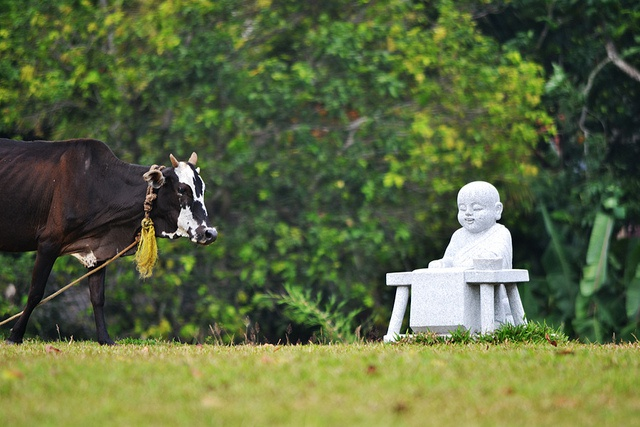Describe the objects in this image and their specific colors. I can see a cow in darkgreen, black, maroon, gray, and lightgray tones in this image. 